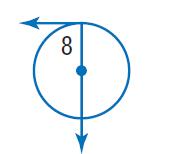Answer the mathemtical geometry problem and directly provide the correct option letter.
Question: Find \angle 8.
Choices: A: 20 B: 70 C: 90 D: 180 C 